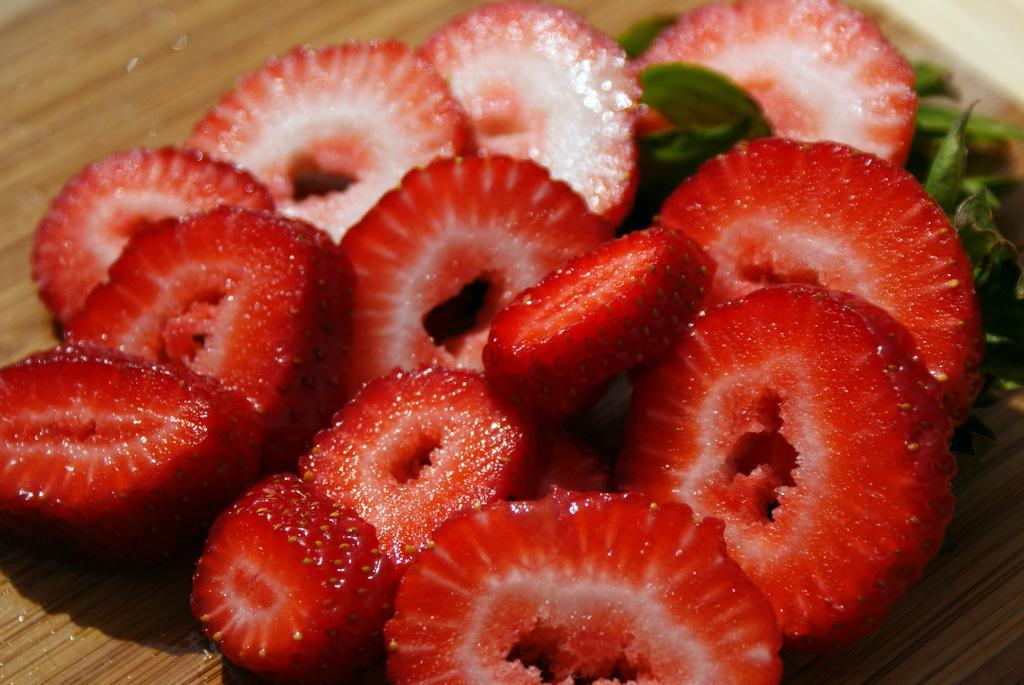In one or two sentences, can you explain what this image depicts? In this image I can see few strawberry pieces and leaves on a wooden surface. 